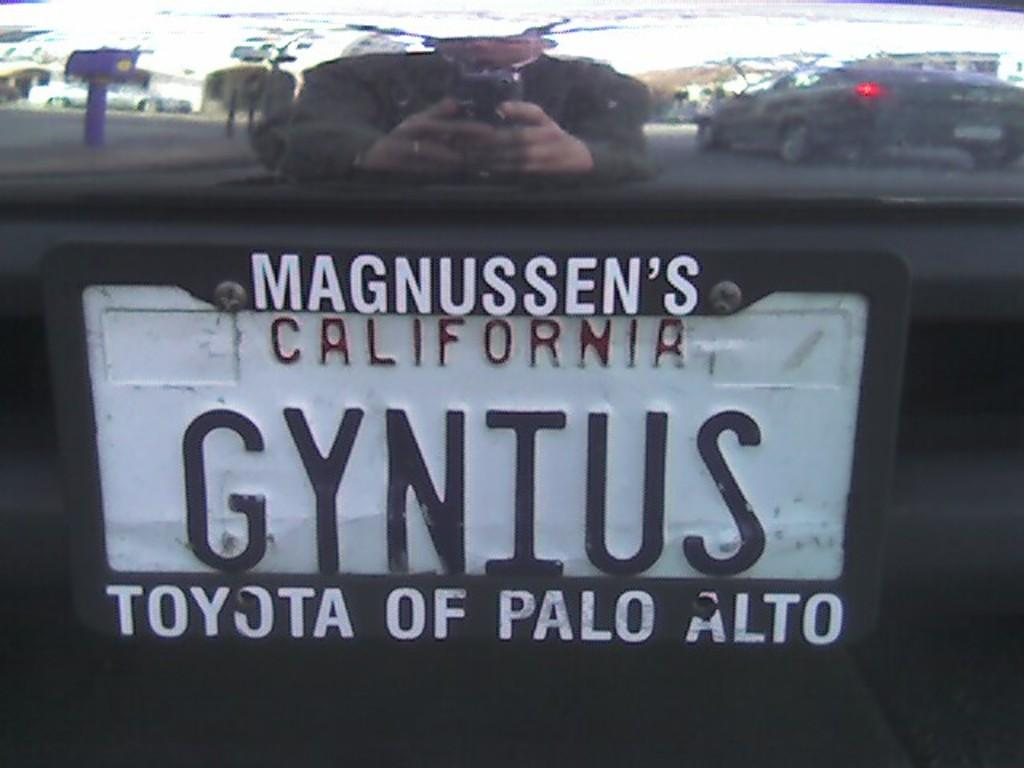<image>
Share a concise interpretation of the image provided. A white California license plate that says gynuis. 